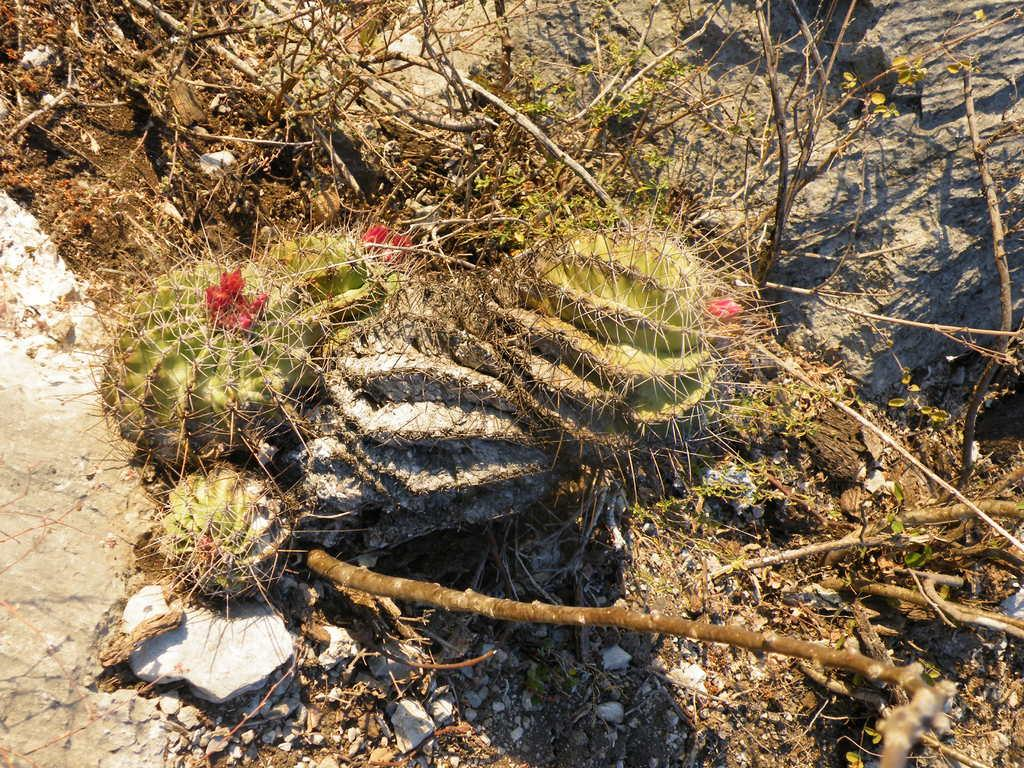What type of plants are in the image? There are cactus plants in the image. What additional features can be seen on the cactus plants? The cactus plants have flowers and branches. What other objects are present in the image? There are rocks in the image. What is the purpose of the box in the image? There is no box present in the image. How does the behavior of the cactus plants change throughout the day? The provided facts do not give information about the behavior of the cactus plants throughout the day. 